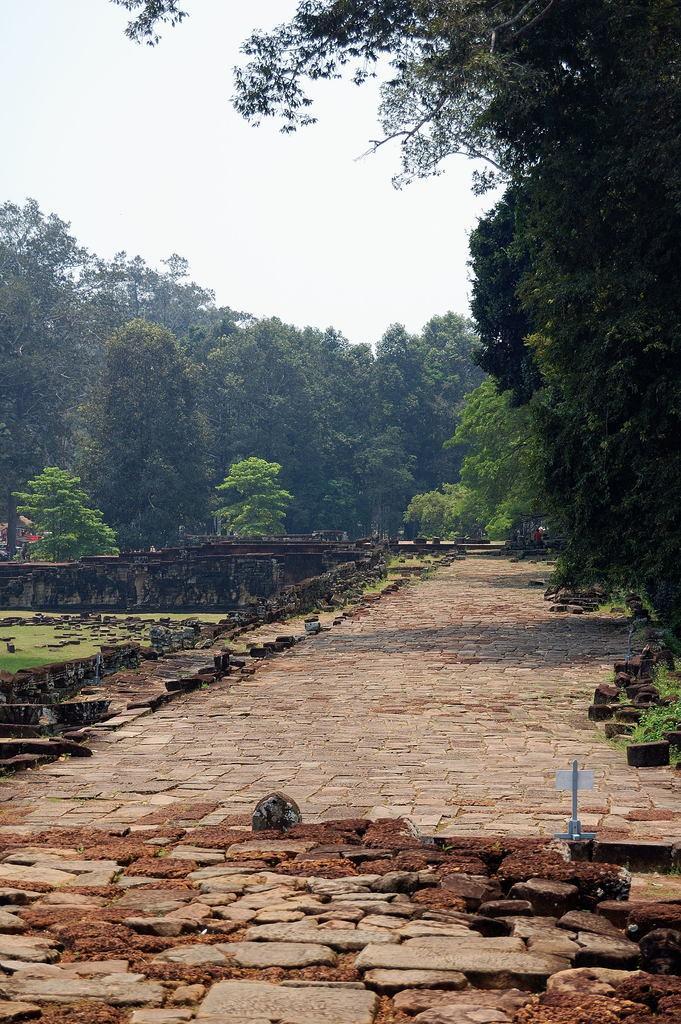In one or two sentences, can you explain what this image depicts? In the center of the image there is a road, one white color object, stones, one round shape object and a few other objects. In the background, we can see the sky, clouds, trees, one bridge, stones, grass, few people and a few other objects. 